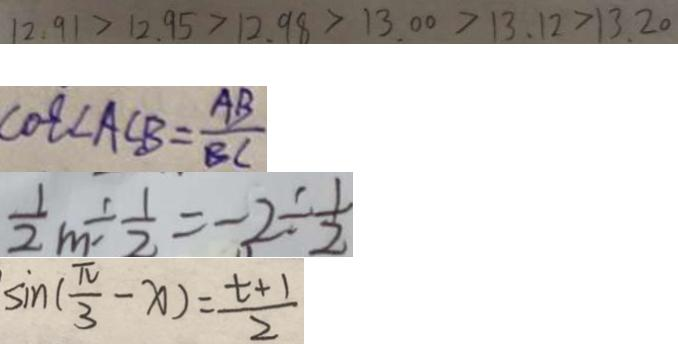<formula> <loc_0><loc_0><loc_500><loc_500>1 2 . 9 1 > 1 2 . 9 5 > 1 2 . 9 8 > 1 3 . 0 0 > 1 3 . 1 2 > 1 3 . 2 0 
 \cos \angle A C B = \frac { A B } { B C } 
 \frac { 1 } { 2 } m \div \frac { 1 } { 2 } = - 2 \div \frac { 1 } { 2 } 
 \sin ( \frac { \pi } { 3 } - x ) = \frac { t + 1 } { 2 }</formula> 